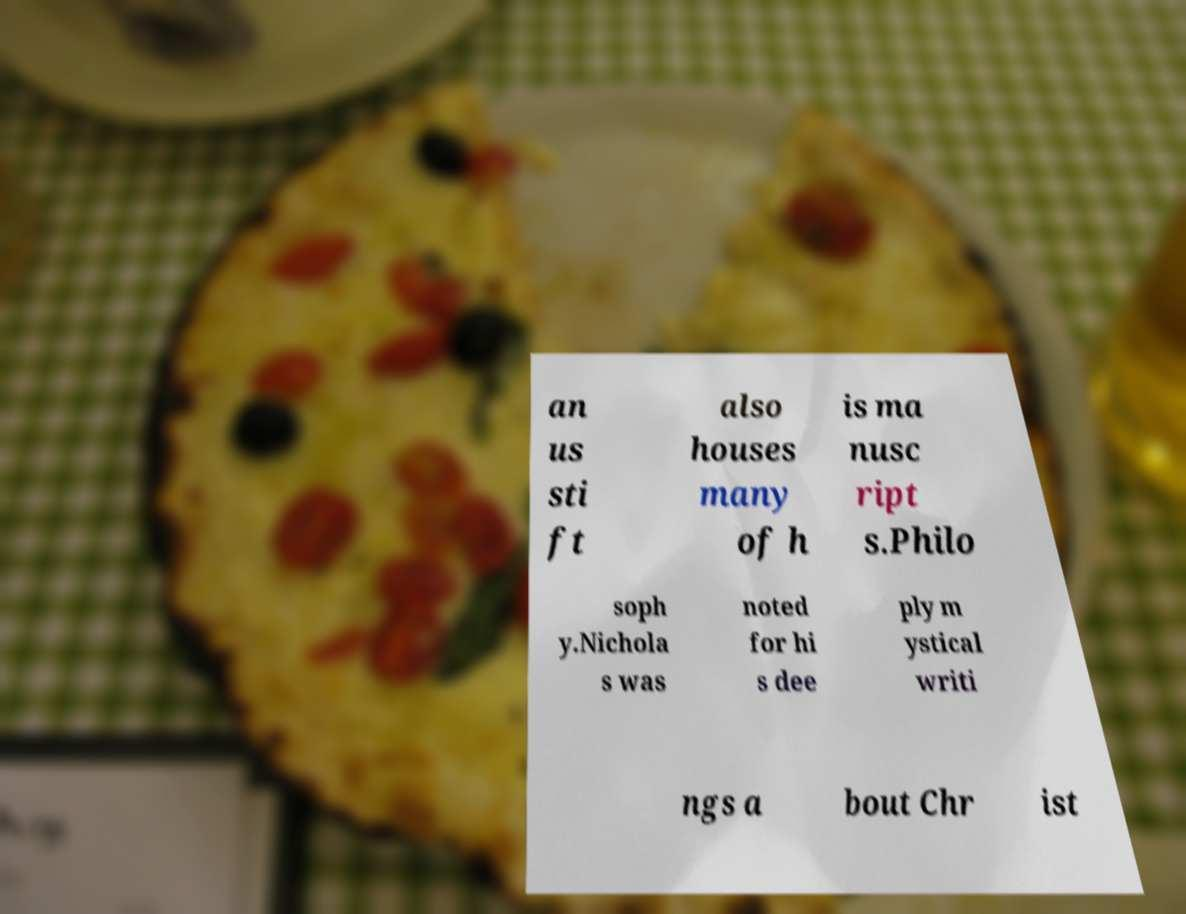Could you extract and type out the text from this image? an us sti ft also houses many of h is ma nusc ript s.Philo soph y.Nichola s was noted for hi s dee ply m ystical writi ngs a bout Chr ist 